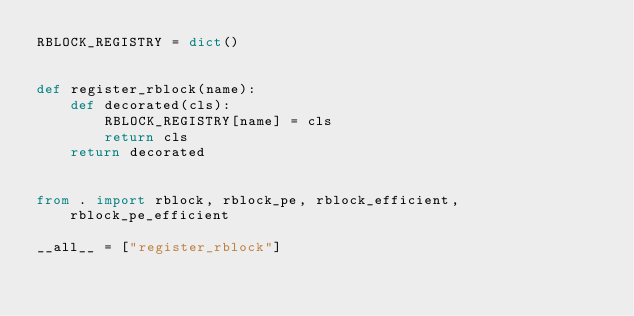<code> <loc_0><loc_0><loc_500><loc_500><_Python_>RBLOCK_REGISTRY = dict()


def register_rblock(name):
    def decorated(cls):
        RBLOCK_REGISTRY[name] = cls
        return cls
    return decorated


from . import rblock, rblock_pe, rblock_efficient, rblock_pe_efficient

__all__ = ["register_rblock"]</code> 